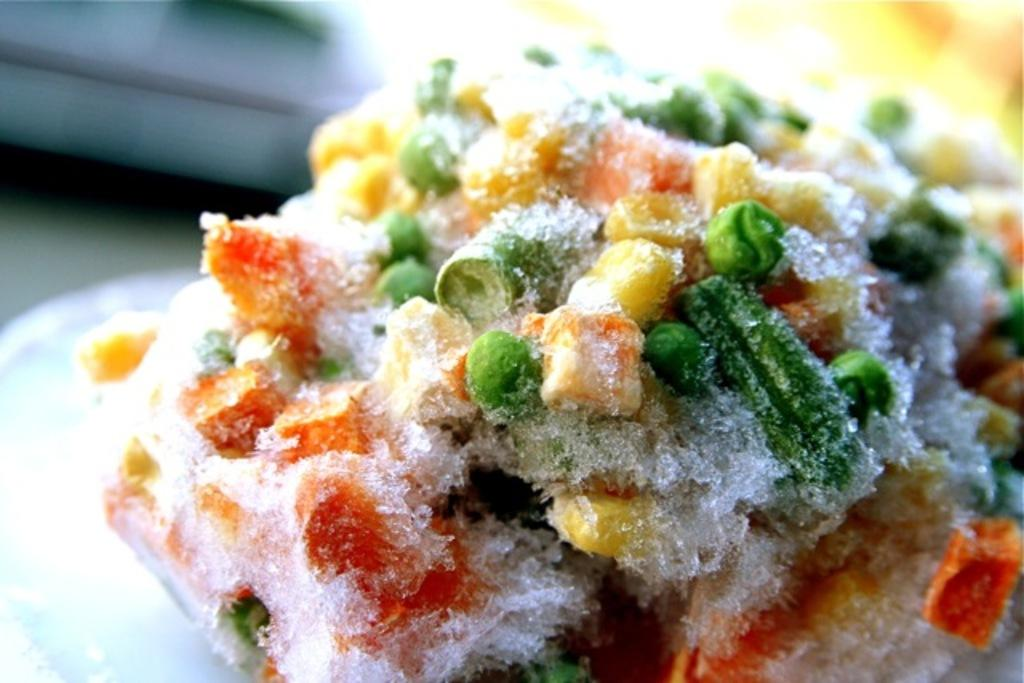What type of food is visible in the image? There is frozen food in the image. How is the frozen food arranged or presented? The frozen food is placed on a plate. What type of copper material is present in the image? There is no copper material present in the image. 